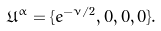<formula> <loc_0><loc_0><loc_500><loc_500>\mathfrak { U } ^ { \alpha } = \{ e ^ { - \nu / 2 } , 0 , 0 , 0 \} .</formula> 